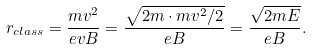<formula> <loc_0><loc_0><loc_500><loc_500>r _ { c l a s s } = \frac { m v ^ { 2 } } { e v B } = \frac { \sqrt { 2 m \cdot m v ^ { 2 } / 2 } } { e B } = \frac { \sqrt { 2 m E } } { e B } .</formula> 